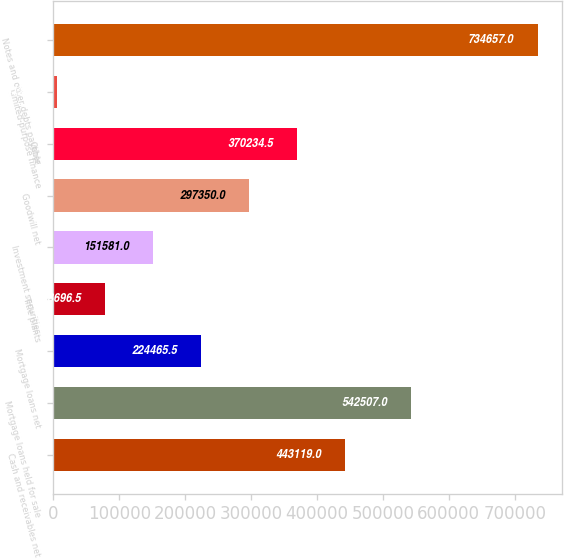<chart> <loc_0><loc_0><loc_500><loc_500><bar_chart><fcel>Cash and receivables net<fcel>Mortgage loans held for sale<fcel>Mortgage loans net<fcel>Title plants<fcel>Investment securities<fcel>Goodwill net<fcel>Other<fcel>Limited-purpose finance<fcel>Notes and other debts payable<nl><fcel>443119<fcel>542507<fcel>224466<fcel>78696.5<fcel>151581<fcel>297350<fcel>370234<fcel>5812<fcel>734657<nl></chart> 